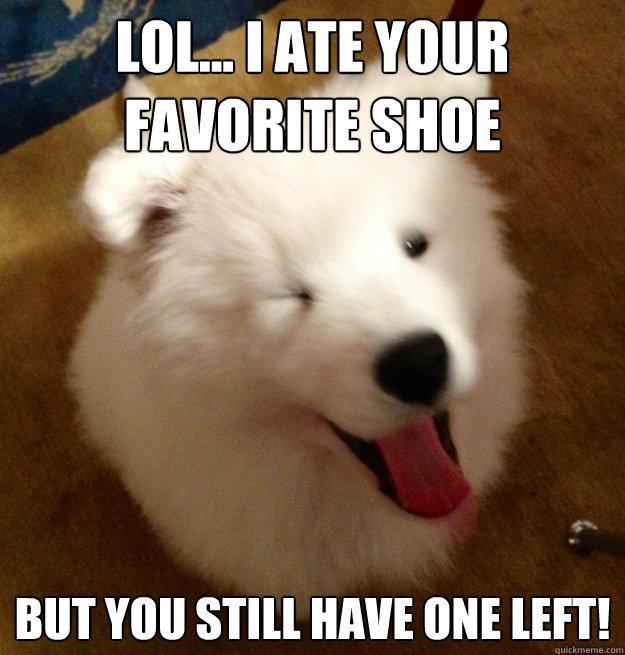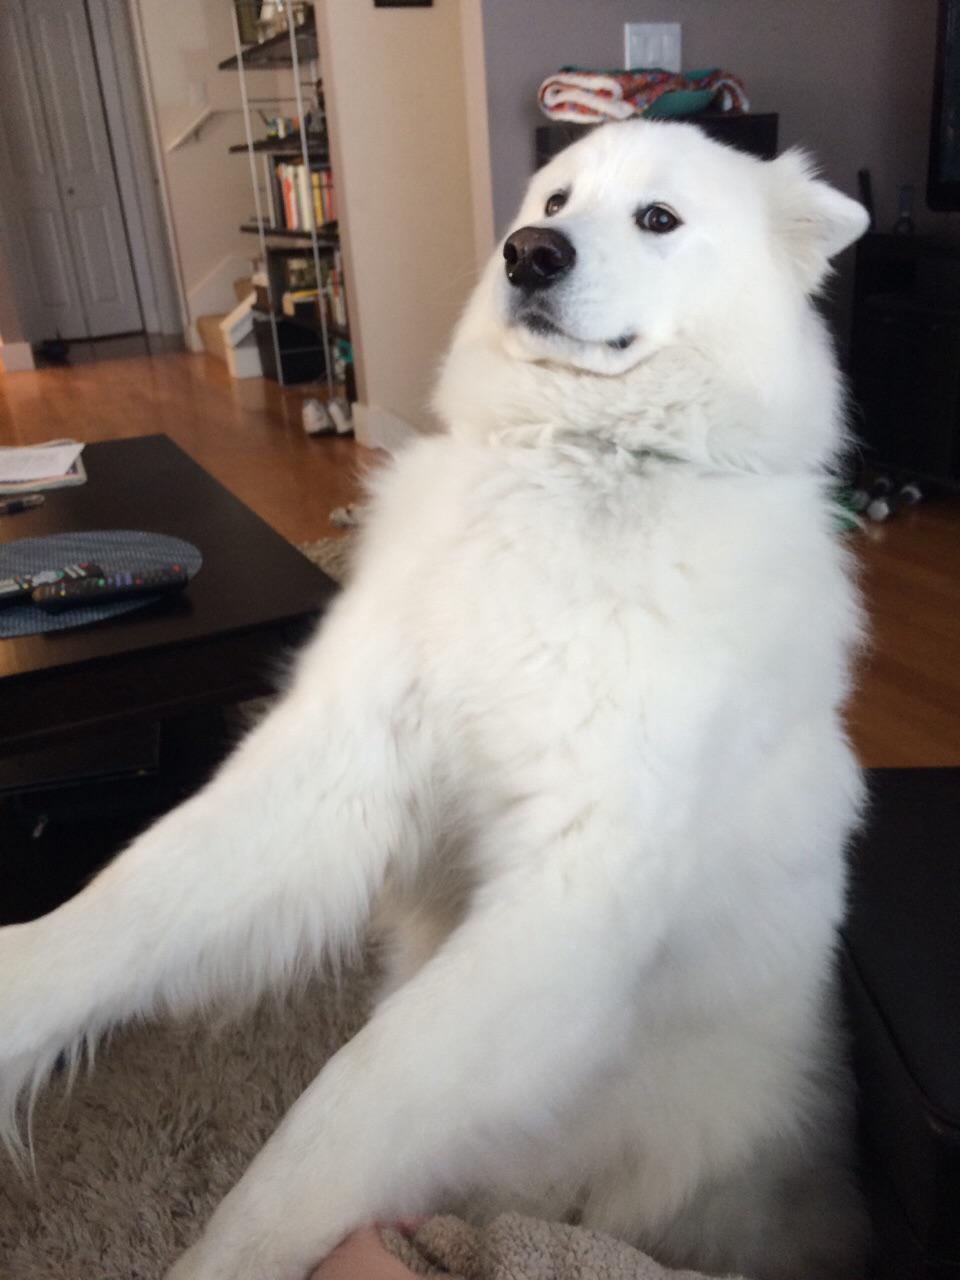The first image is the image on the left, the second image is the image on the right. Examine the images to the left and right. Is the description "There are at least three fluffy white dogs." accurate? Answer yes or no. No. 